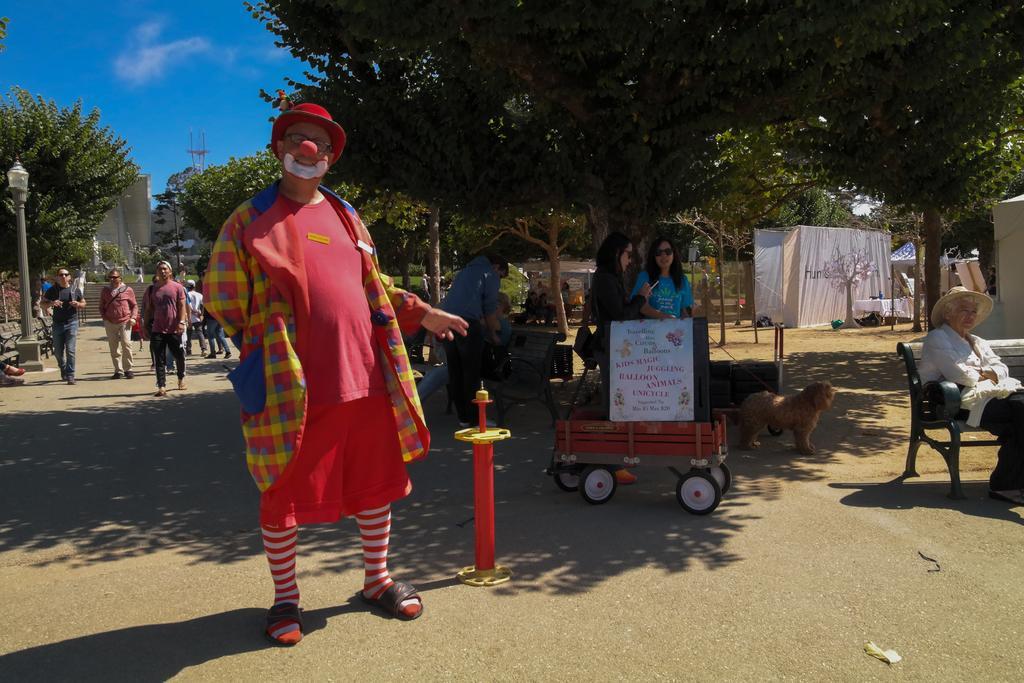How would you summarize this image in a sentence or two? There are group of people standing in the road and the back ground there is tree , tent , street light , dog , building and sky. 